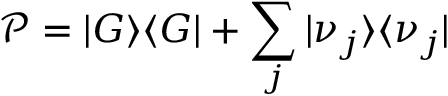Convert formula to latex. <formula><loc_0><loc_0><loc_500><loc_500>\mathcal { P } = | G \rangle \langle G | + \sum _ { j } | \nu _ { j } \rangle \langle \nu _ { j } |</formula> 